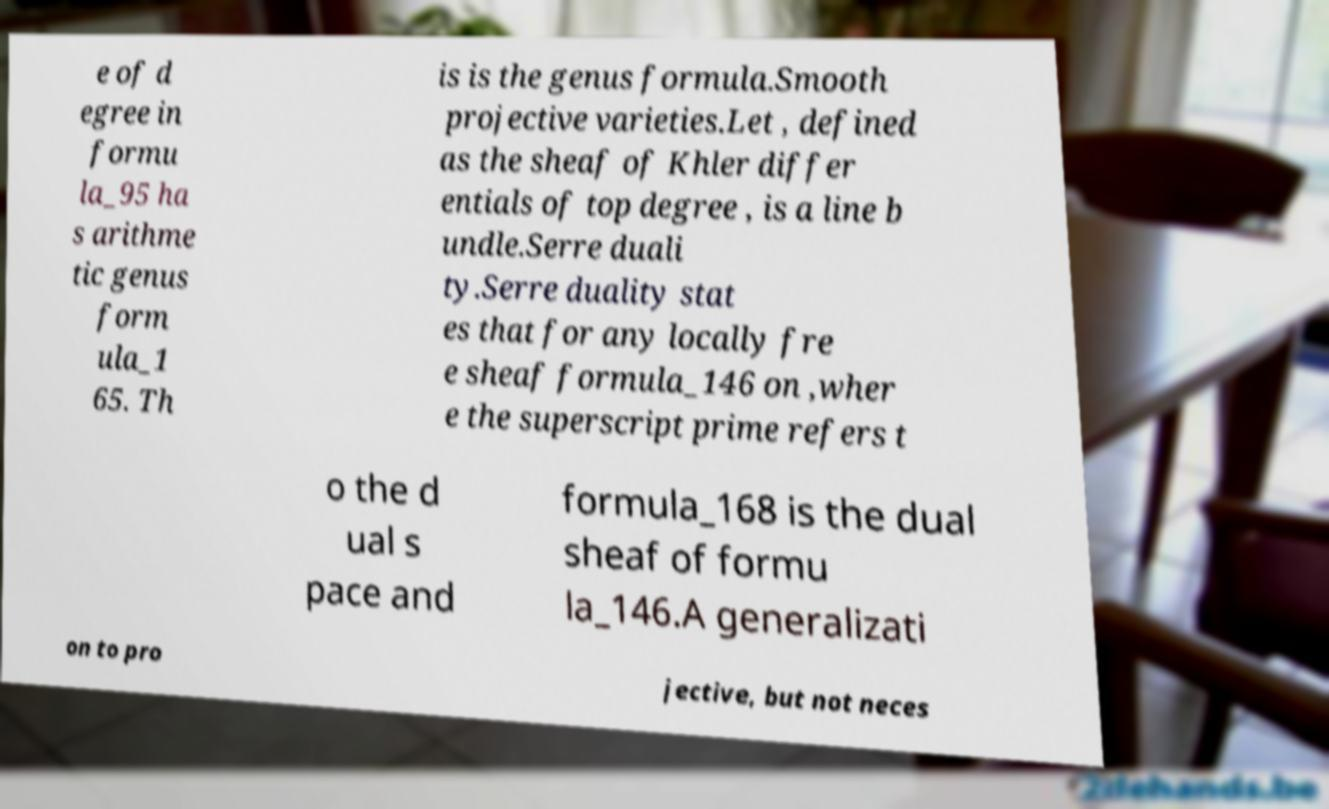Can you read and provide the text displayed in the image?This photo seems to have some interesting text. Can you extract and type it out for me? e of d egree in formu la_95 ha s arithme tic genus form ula_1 65. Th is is the genus formula.Smooth projective varieties.Let , defined as the sheaf of Khler differ entials of top degree , is a line b undle.Serre duali ty.Serre duality stat es that for any locally fre e sheaf formula_146 on ,wher e the superscript prime refers t o the d ual s pace and formula_168 is the dual sheaf of formu la_146.A generalizati on to pro jective, but not neces 